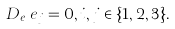Convert formula to latex. <formula><loc_0><loc_0><loc_500><loc_500>D _ { e _ { i } } e _ { j } = 0 , i , j \in \{ 1 , 2 , 3 \} .</formula> 